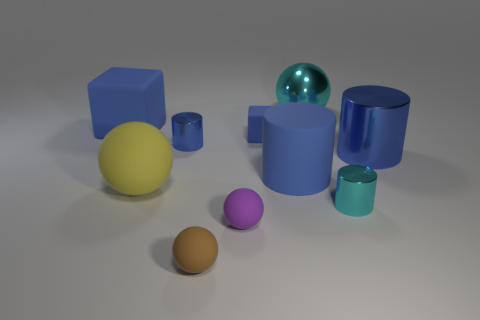The tiny metallic thing that is behind the cyan metal cylinder is what color?
Your answer should be very brief. Blue. Does the purple rubber object have the same size as the yellow ball on the left side of the tiny brown ball?
Keep it short and to the point. No. There is a matte object that is in front of the big matte sphere and behind the tiny brown rubber object; what is its size?
Your answer should be compact. Small. Is there a big gray cylinder that has the same material as the large yellow object?
Your answer should be very brief. No. What shape is the purple matte thing?
Your answer should be very brief. Sphere. Do the yellow matte thing and the brown matte sphere have the same size?
Your answer should be compact. No. What number of other things are there of the same shape as the tiny cyan metallic object?
Provide a short and direct response. 3. The cyan metal thing that is behind the big blue metal cylinder has what shape?
Give a very brief answer. Sphere. There is a blue object that is in front of the big metallic cylinder; is it the same shape as the tiny metallic object that is right of the tiny brown thing?
Make the answer very short. Yes. Are there the same number of tiny cyan things that are in front of the tiny rubber cube and small brown spheres?
Your answer should be very brief. Yes. 